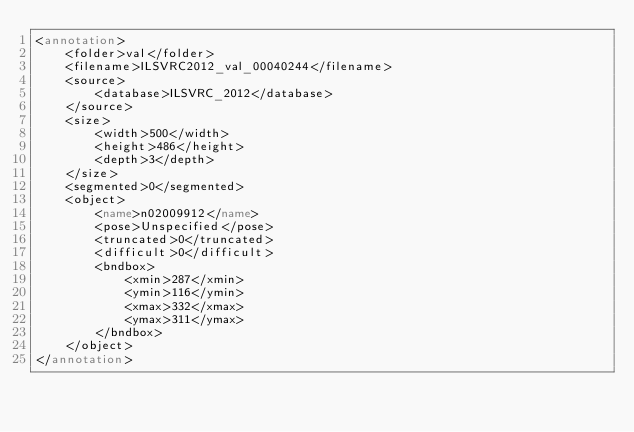Convert code to text. <code><loc_0><loc_0><loc_500><loc_500><_XML_><annotation>
	<folder>val</folder>
	<filename>ILSVRC2012_val_00040244</filename>
	<source>
		<database>ILSVRC_2012</database>
	</source>
	<size>
		<width>500</width>
		<height>486</height>
		<depth>3</depth>
	</size>
	<segmented>0</segmented>
	<object>
		<name>n02009912</name>
		<pose>Unspecified</pose>
		<truncated>0</truncated>
		<difficult>0</difficult>
		<bndbox>
			<xmin>287</xmin>
			<ymin>116</ymin>
			<xmax>332</xmax>
			<ymax>311</ymax>
		</bndbox>
	</object>
</annotation></code> 